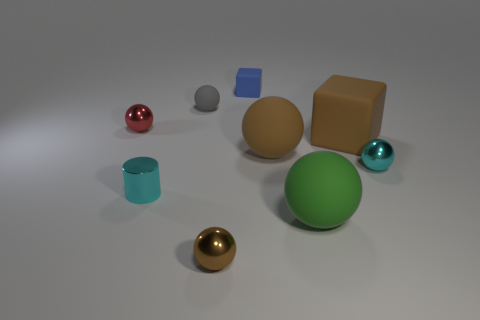There is a small cyan thing that is the same shape as the big green thing; what is its material?
Provide a succinct answer. Metal. What material is the small sphere that is both behind the large green object and on the right side of the tiny gray rubber object?
Offer a very short reply. Metal. Is the number of small brown balls right of the big green matte object less than the number of gray rubber spheres that are left of the cyan metal sphere?
Make the answer very short. Yes. How many other objects are there of the same size as the cyan sphere?
Give a very brief answer. 5. What shape is the small cyan metal object on the left side of the brown ball in front of the cyan shiny object right of the tiny brown metallic ball?
Offer a terse response. Cylinder. How many blue objects are rubber cubes or cylinders?
Keep it short and to the point. 1. What number of small blue matte objects are behind the small cube that is behind the small red metallic thing?
Your response must be concise. 0. Is there any other thing that has the same color as the tiny cylinder?
Provide a short and direct response. Yes. There is a tiny red object that is the same material as the small brown sphere; what is its shape?
Provide a short and direct response. Sphere. Are the small cyan thing to the left of the large brown block and the small brown ball to the left of the small blue matte object made of the same material?
Ensure brevity in your answer.  Yes. 